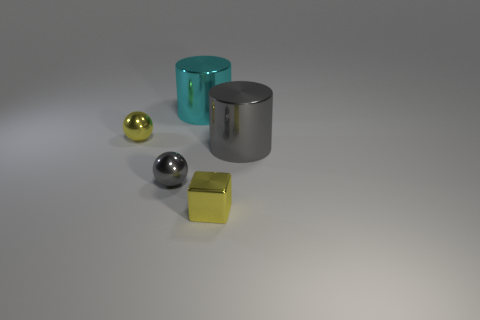There is a thing that is the same color as the block; what size is it?
Provide a short and direct response. Small. Is the color of the small object to the left of the tiny gray thing the same as the block?
Provide a short and direct response. Yes. Are there any balls of the same color as the block?
Make the answer very short. Yes. How big is the shiny cylinder behind the shiny ball behind the tiny gray shiny ball?
Your response must be concise. Large. Is the number of tiny gray things that are on the right side of the small gray shiny thing less than the number of gray things to the left of the gray shiny cylinder?
Your answer should be very brief. Yes. There is a cylinder on the right side of the tiny cube; does it have the same color as the ball that is in front of the gray cylinder?
Your answer should be compact. Yes. What is the material of the tiny object that is both behind the metallic block and to the right of the tiny yellow ball?
Your answer should be very brief. Metal. Is there a shiny cylinder?
Provide a short and direct response. Yes. The tiny gray thing that is made of the same material as the large gray thing is what shape?
Offer a terse response. Sphere. Does the small gray object have the same shape as the gray object that is behind the gray ball?
Give a very brief answer. No. 